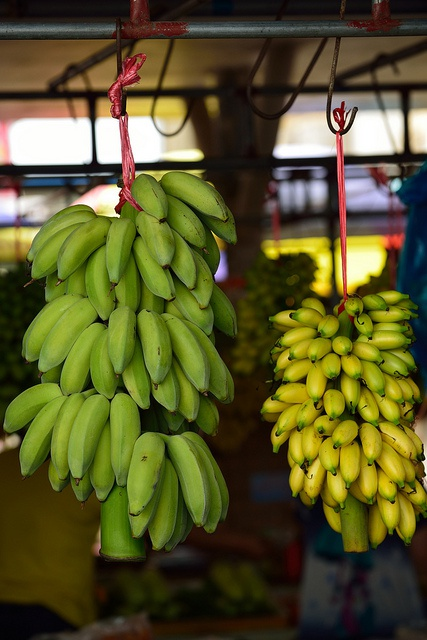Describe the objects in this image and their specific colors. I can see banana in black, darkgreen, and olive tones, banana in black, olive, and gold tones, banana in black, olive, and darkgreen tones, banana in black tones, and banana in black, olive, and darkgreen tones in this image. 